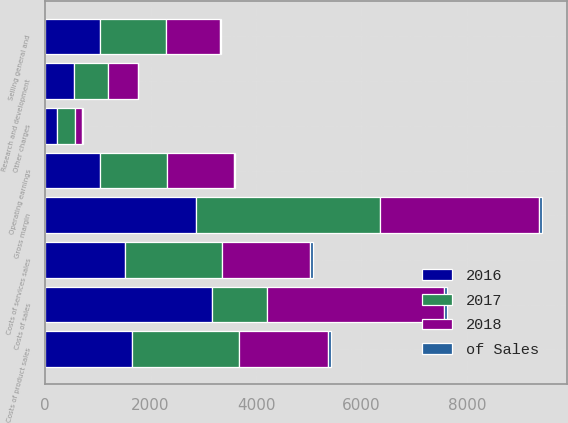Convert chart to OTSL. <chart><loc_0><loc_0><loc_500><loc_500><stacked_bar_chart><ecel><fcel>Costs of product sales<fcel>Costs of services sales<fcel>Costs of sales<fcel>Gross margin<fcel>Selling general and<fcel>Research and development<fcel>Other charges<fcel>Operating earnings<nl><fcel>2017<fcel>2035<fcel>1828<fcel>1044<fcel>3480<fcel>1254<fcel>637<fcel>334<fcel>1255<nl><fcel>of Sales<fcel>45.6<fcel>63.5<fcel>52.6<fcel>47.4<fcel>17.1<fcel>8.7<fcel>4.5<fcel>17.1<nl><fcel>2018<fcel>1686<fcel>1670<fcel>3356<fcel>3024<fcel>1025<fcel>568<fcel>147<fcel>1284<nl><fcel>2016<fcel>1649<fcel>1520<fcel>3169<fcel>2869<fcel>1044<fcel>553<fcel>224<fcel>1048<nl></chart> 